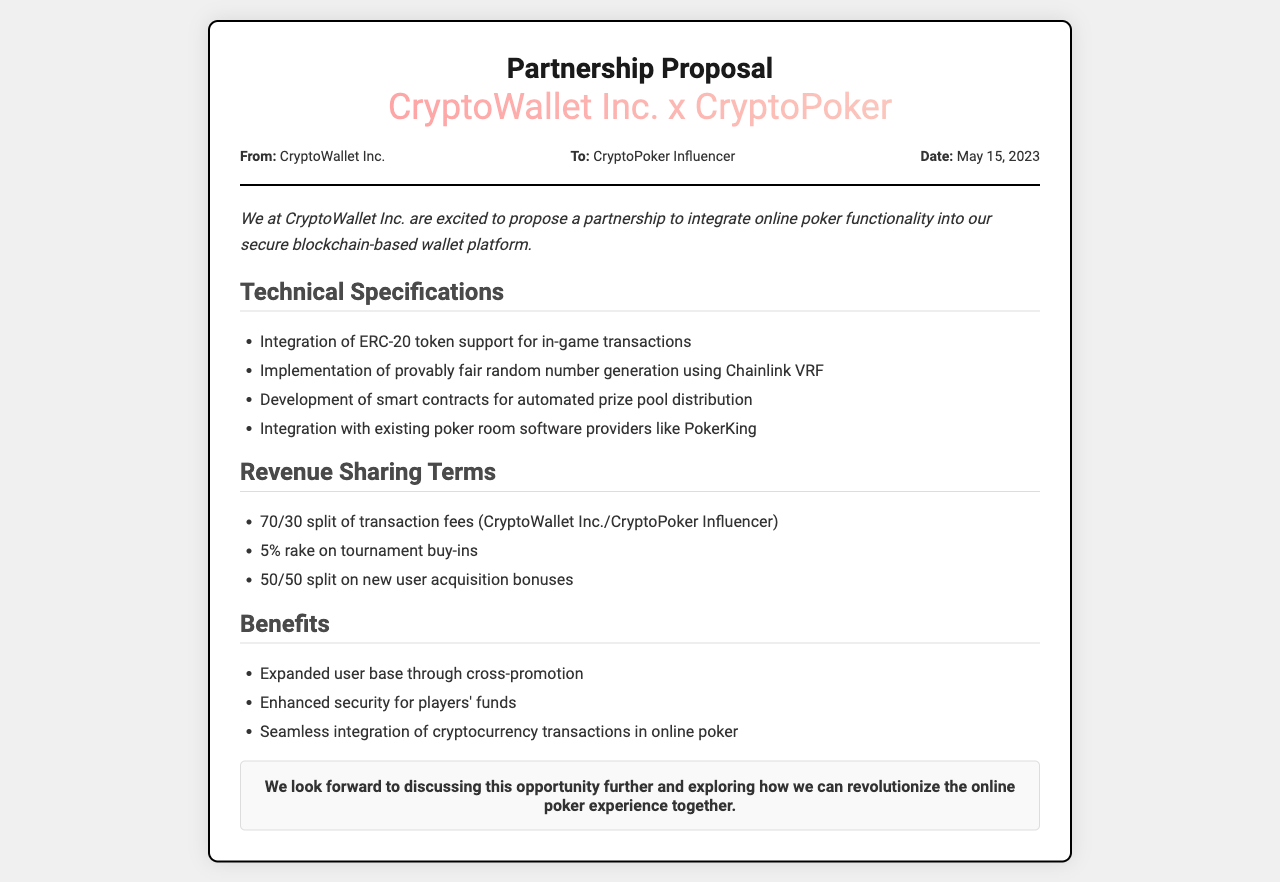What company is proposing the partnership? The document states that the proposal is from CryptoWallet Inc.
Answer: CryptoWallet Inc Who is the proposal addressed to? The document specifies that the proposal is directed to the CryptoPoker Influencer.
Answer: CryptoPoker Influencer What is the date of the proposal? The document mentions that the proposal was dated May 15, 2023.
Answer: May 15, 2023 What is the revenue sharing split for transaction fees? The document provides a 70/30 split of transaction fees between CryptoWallet Inc. and the CryptoPoker Influencer.
Answer: 70/30 Which technology is mentioned for random number generation? The document refers to Chainlink VRF as the technology used for random number generation.
Answer: Chainlink VRF What type of token support is being integrated? The document states that ERC-20 token support will be integrated for in-game transactions.
Answer: ERC-20 What is the rake percentage on tournament buy-ins? According to the proposal, there is a 5% rake on tournament buy-ins.
Answer: 5% What benefit is associated with security for players' funds? The document mentions enhanced security as a specific benefit for players' funds.
Answer: Enhanced security What percentage is allocated for new user acquisition bonuses? The document indicates a 50/50 split on new user acquisition bonuses.
Answer: 50/50 